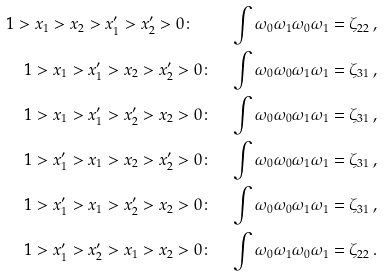<formula> <loc_0><loc_0><loc_500><loc_500>1 > x _ { 1 } > x _ { 2 } > x _ { 1 } ^ { \prime } > x _ { 2 } ^ { \prime } > 0 \colon \quad \int \omega _ { 0 } \omega _ { 1 } \omega _ { 0 } \omega _ { 1 } = \zeta _ { 2 2 } \, , \\ 1 > x _ { 1 } > x _ { 1 } ^ { \prime } > x _ { 2 } > x _ { 2 } ^ { \prime } > 0 \colon \quad \int \omega _ { 0 } \omega _ { 0 } \omega _ { 1 } \omega _ { 1 } = \zeta _ { 3 1 } \, , \\ 1 > x _ { 1 } > x _ { 1 } ^ { \prime } > x _ { 2 } ^ { \prime } > x _ { 2 } > 0 \colon \quad \int \omega _ { 0 } \omega _ { 0 } \omega _ { 1 } \omega _ { 1 } = \zeta _ { 3 1 } \, , \\ 1 > x _ { 1 } ^ { \prime } > x _ { 1 } > x _ { 2 } > x _ { 2 } ^ { \prime } > 0 \colon \quad \int \omega _ { 0 } \omega _ { 0 } \omega _ { 1 } \omega _ { 1 } = \zeta _ { 3 1 } \, , \\ 1 > x _ { 1 } ^ { \prime } > x _ { 1 } > x _ { 2 } ^ { \prime } > x _ { 2 } > 0 \colon \quad \int \omega _ { 0 } \omega _ { 0 } \omega _ { 1 } \omega _ { 1 } = \zeta _ { 3 1 } \, , \\ 1 > x _ { 1 } ^ { \prime } > x _ { 2 } ^ { \prime } > x _ { 1 } > x _ { 2 } > 0 \colon \quad \int \omega _ { 0 } \omega _ { 1 } \omega _ { 0 } \omega _ { 1 } = \zeta _ { 2 2 } \, .</formula> 